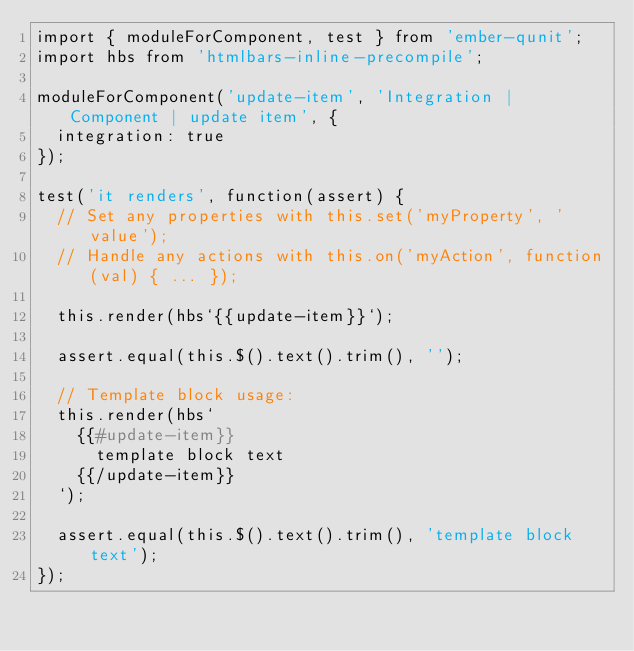Convert code to text. <code><loc_0><loc_0><loc_500><loc_500><_JavaScript_>import { moduleForComponent, test } from 'ember-qunit';
import hbs from 'htmlbars-inline-precompile';

moduleForComponent('update-item', 'Integration | Component | update item', {
  integration: true
});

test('it renders', function(assert) {
  // Set any properties with this.set('myProperty', 'value');
  // Handle any actions with this.on('myAction', function(val) { ... });

  this.render(hbs`{{update-item}}`);

  assert.equal(this.$().text().trim(), '');

  // Template block usage:
  this.render(hbs`
    {{#update-item}}
      template block text
    {{/update-item}}
  `);

  assert.equal(this.$().text().trim(), 'template block text');
});
</code> 